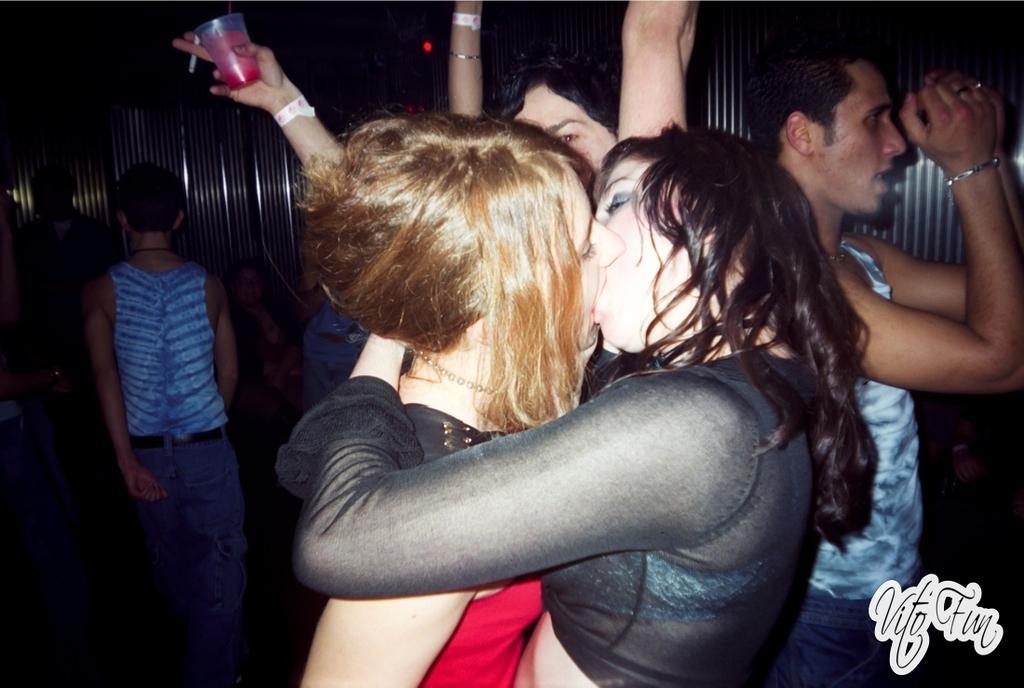Can you describe this image briefly? In this image, we can see two persons wearing clothes kissing each other. There is an another person on the left and on the right side of the image. 